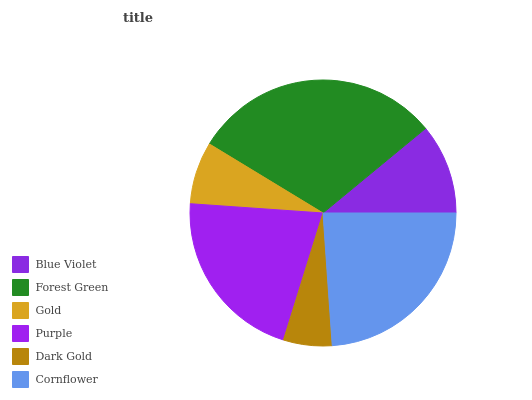Is Dark Gold the minimum?
Answer yes or no. Yes. Is Forest Green the maximum?
Answer yes or no. Yes. Is Gold the minimum?
Answer yes or no. No. Is Gold the maximum?
Answer yes or no. No. Is Forest Green greater than Gold?
Answer yes or no. Yes. Is Gold less than Forest Green?
Answer yes or no. Yes. Is Gold greater than Forest Green?
Answer yes or no. No. Is Forest Green less than Gold?
Answer yes or no. No. Is Purple the high median?
Answer yes or no. Yes. Is Blue Violet the low median?
Answer yes or no. Yes. Is Forest Green the high median?
Answer yes or no. No. Is Cornflower the low median?
Answer yes or no. No. 